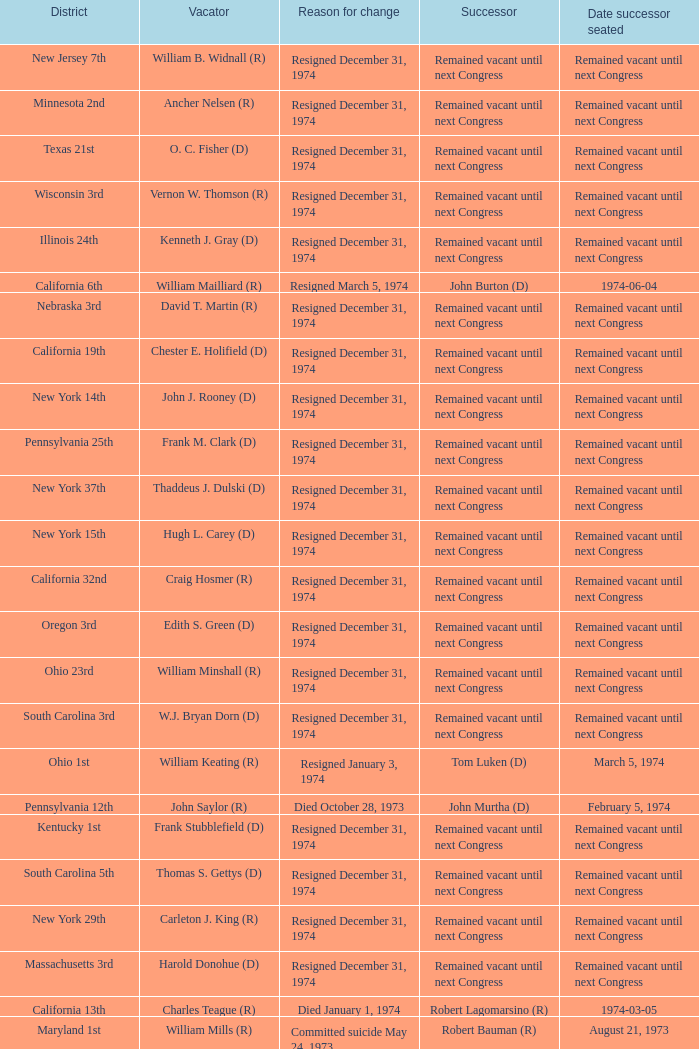Who was the vacator when the date successor seated was august 21, 1973? William Mills (R). 